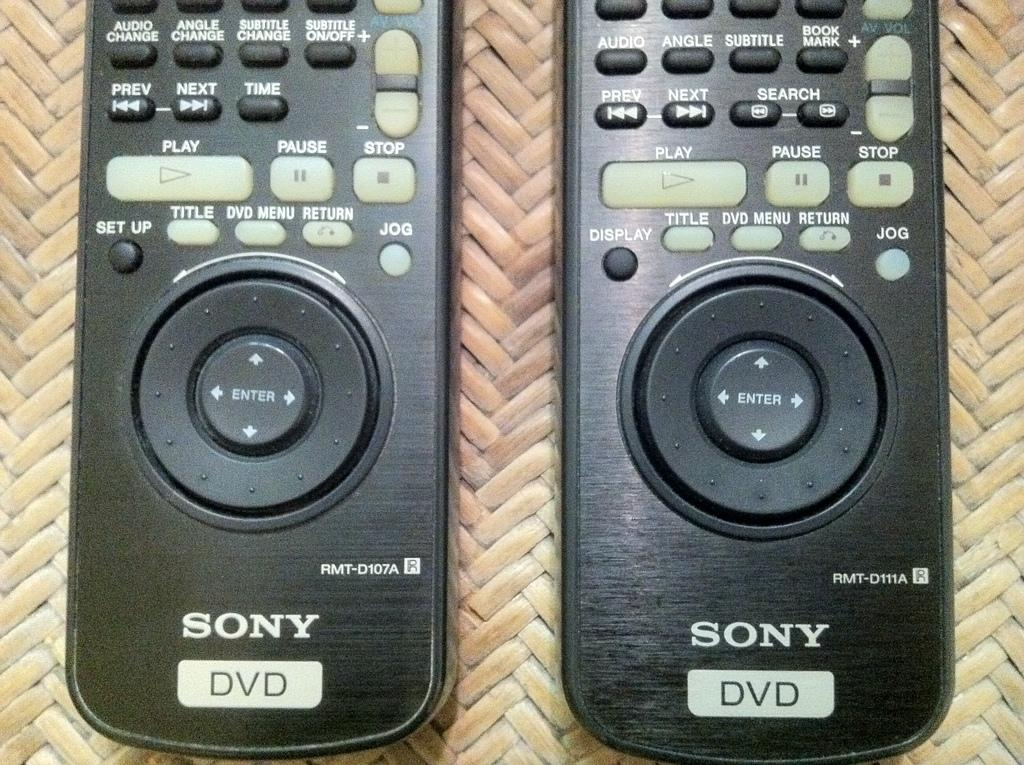<image>
Provide a brief description of the given image. The bottom half of two Sony DVD remote controls. 